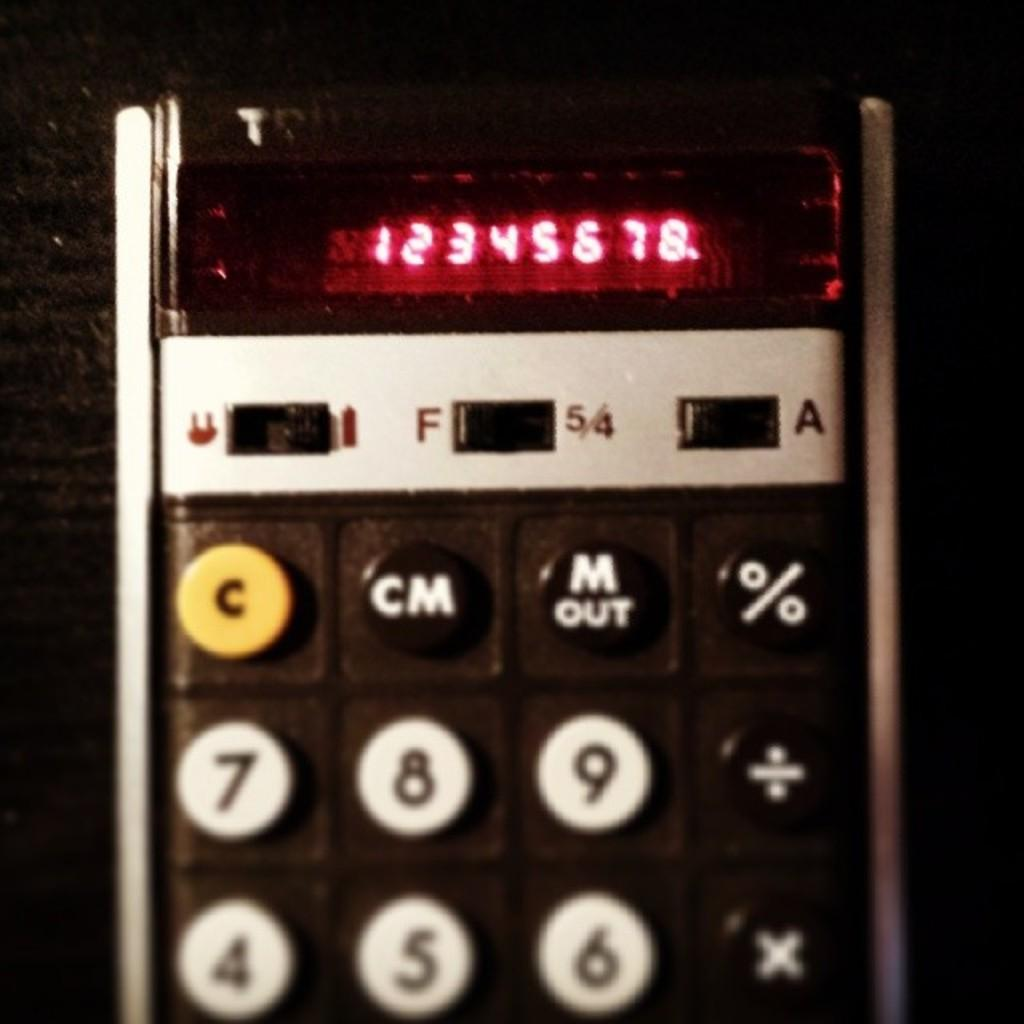<image>
Create a compact narrative representing the image presented. A calculator has the numbers 12345678 on the screen. 